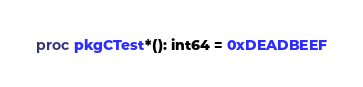Convert code to text. <code><loc_0><loc_0><loc_500><loc_500><_Nim_>proc pkgCTest*(): int64 = 0xDEADBEEF</code> 